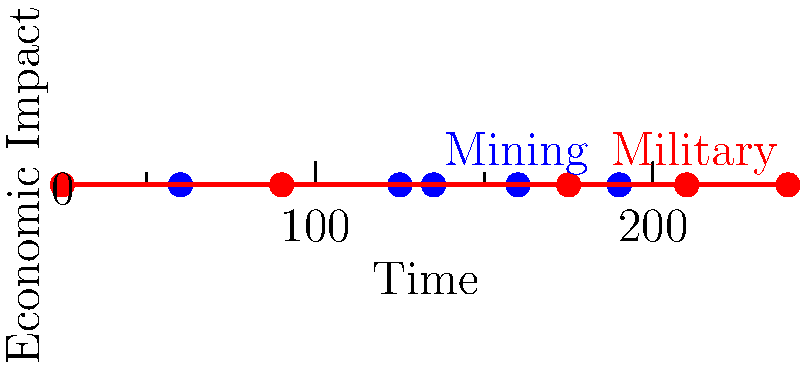Based on the economic impact vectors shown in the graph for mining and military industries in Tooele's history, which industry shows a more consistent upward trend, and what might this suggest about the area's economic development? To answer this question, we need to analyze the trends of both industries:

1. Mining industry (blue line):
   - Starts at a higher point than the military industry
   - Shows initial growth
   - Reaches a peak in the middle of the timeline
   - Experiences a decline towards the end

2. Military industry (red line):
   - Starts at a lower point than the mining industry
   - Shows consistent growth throughout the timeline
   - Surpasses the mining industry in economic impact towards the end
   - Continues to grow even as mining declines

3. Comparison of trends:
   - The military industry shows a more consistent upward trend
   - The mining industry shows more fluctuation and eventual decline

4. Implications for Tooele's economic development:
   - The consistent growth of the military industry suggests:
     a) Increased military presence or expansion of military facilities
     b) More stable long-term employment opportunities
     c) Potential for associated industries and services to develop around military activities
   - The decline in mining suggests:
     a) Possible depletion of mineral resources
     b) Shift away from resource extraction-based economy
     c) Need for economic diversification

5. Overall economic development:
   - The graph suggests a transition from a mining-dominated economy to one with a stronger military influence
   - This shift likely affected local job markets, population dynamics, and infrastructure development in Tooele
Answer: Military industry; indicates economic transition from mining to military-based economy 